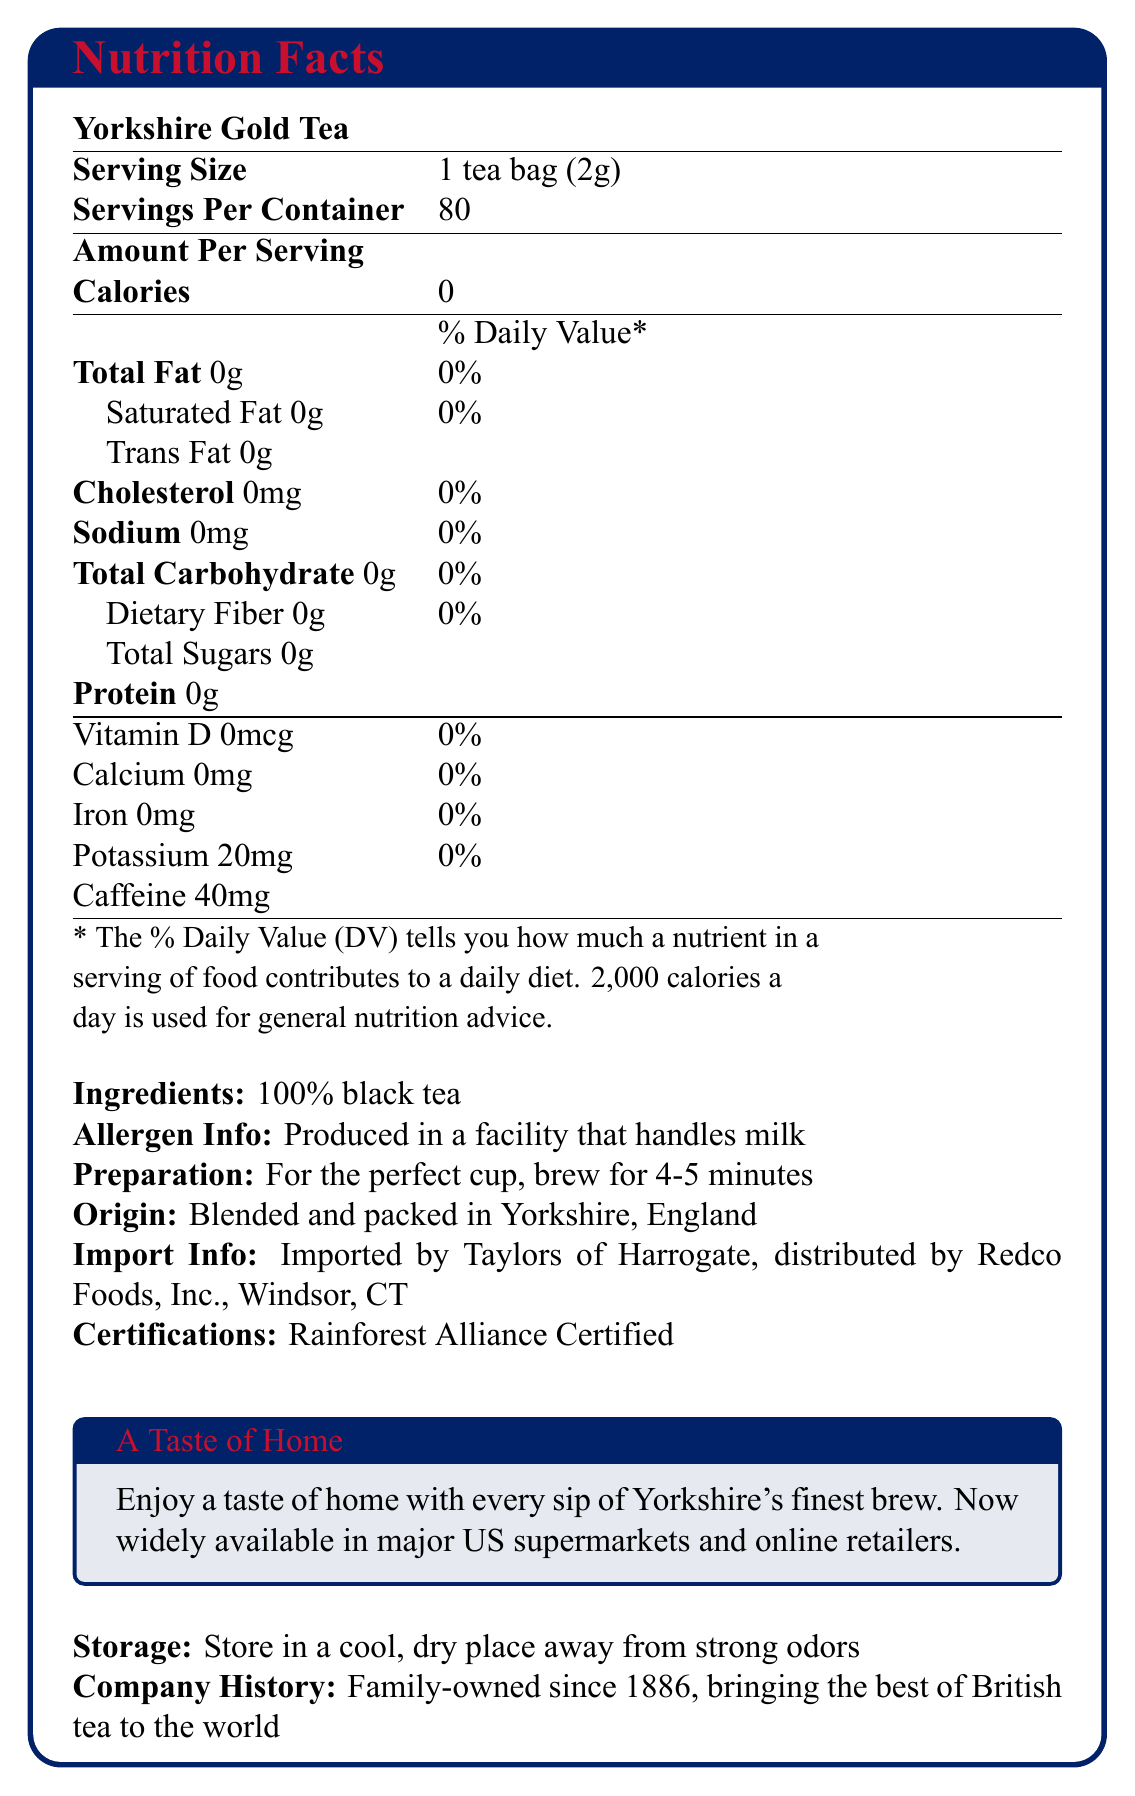How many servings are in a container of Yorkshire Gold Tea? The document states "Servings Per Container: 80," indicating there are 80 servings in a container.
Answer: 80 What is the serving size for Yorkshire Gold Tea? The document specifies the serving size as "1 tea bag (2g)."
Answer: 1 tea bag (2g) What is the amount of caffeine in one serving of Yorkshire Gold Tea? According to the document, the caffeine content per serving is listed as "Caffeine: 40mg."
Answer: 40mg Does Yorkshire Gold Tea contain any calories? The document shows "Calories: 0," indicating there are no calories.
Answer: No From where is Yorkshire Gold Tea imported? The document mentions the import information: "Imported by Taylors of Harrogate, distributed by Redco Foods, Inc., Windsor, CT."
Answer: Taylors of Harrogate, distributed by Redco Foods, Inc., Windsor, CT What certification does Yorkshire Gold Tea hold? The document includes a section on certifications that states Yorkshire Gold Tea is "Rainforest Alliance Certified."
Answer: Rainforest Alliance Certified How long should you brew Yorkshire Gold Tea for the perfect cup? The document states in the preparation instructions "For the perfect cup, brew for 4-5 minutes."
Answer: 4-5 minutes What type of tea is Yorkshire Gold Tea made from? The document lists the ingredients as "100% black tea."
Answer: 100% black tea Which of the following nutrients is NOT present in Yorkshire Gold Tea?
A. Vitamin D
B. Calcium
C. Iron
D. All of the above The document shows that Vitamin D, Calcium, and Iron all have values of 0% DV, indicating none of these nutrients are present.
Answer: D. All of the above Which tea is blended and packed in Yorkshire, England?
i. Twinings 
ii. Yorkshire Gold Tea
iii. Lipton The document mentions "Origin: Blended and packed in Yorkshire, England," specifically referring to Yorkshire Gold Tea.
Answer: ii. Yorkshire Gold Tea Is Yorkshire Gold Tea suitable for someone with a milk allergy? The document states "Allergen Info: Produced in a facility that handles milk."
Answer: No Summarize the key nutritional and product information given in the document. The document provides detailed nutritional facts, ingredients, allergen information, preparation guidelines, import and storage details, and the company history related to Yorkshire Gold Tea.
Answer: Yorkshire Gold Tea provides nutritional information indicating no calories, fats, carbohydrates, or proteins, with a serving size of 1 tea bag (2g) and 80 servings per container. It contains 40mg of caffeine per serving and is made from 100% black tea. The tea originates from Yorkshire, England, and is Rainforest Alliance Certified. It is advised to brew the tea for 4-5 minutes for the best taste. What is the history of the company behind Yorkshire Gold Tea? The document includes a section stating "Family-owned since 1886, bringing the best of British tea to the world."
Answer: Family-owned since 1886 How much sodium is in one serving of Yorkshire Gold Tea? The document shows "Sodium: 0mg" per serving.
Answer: 0mg Can you list all the vitamins and minerals in Yorkshire Gold Tea given their % Daily Value? The document details Vitamin D (0% DV), Calcium (0% DV), Iron (0% DV), and Potassium (0% DV).
Answer: Vitamin D: 0% DV, Calcium: 0% DV, Iron: 0% DV, Potassium: 0% DV Does Yorkshire Gold Tea contain any dietary fiber? The document states "Dietary Fiber: 0g," indicating there is no dietary fiber in the tea.
Answer: No Where in the US can you find Yorkshire Gold Tea? The document mentions that the tea is "Now widely available in major US supermarkets and online retailers."
Answer: Major US supermarkets and online retailers What is the total carbohydrate content per serving in Yorkshire Gold Tea? The document lists "Total Carbohydrate: 0g."
Answer: 0g What is the unique aspect of Yorkshire Gold Tea that appeals to British expatriates? The document includes a section titled "A Taste of Home," emphasizing that the tea offers a nostalgic experience for British expatriates.
Answer: A taste of home Does Yorkshire Gold Tea include any added sugars? The document indicates "Total Sugars: 0g," showing that there are no added sugars in the tea.
Answer: No Which country is the tea blended and packed in? The document specifies "Blended and packed in Yorkshire, England."
Answer: England How should Yorkshire Gold Tea be stored? The document specifies "Store in a cool, dry place away from strong odors."
Answer: In a cool, dry place away from strong odors What is the annual revenue of the company behind Yorkshire Gold Tea? The provided document does not include financial information such as the annual revenue of the company.
Answer: Cannot be determined 